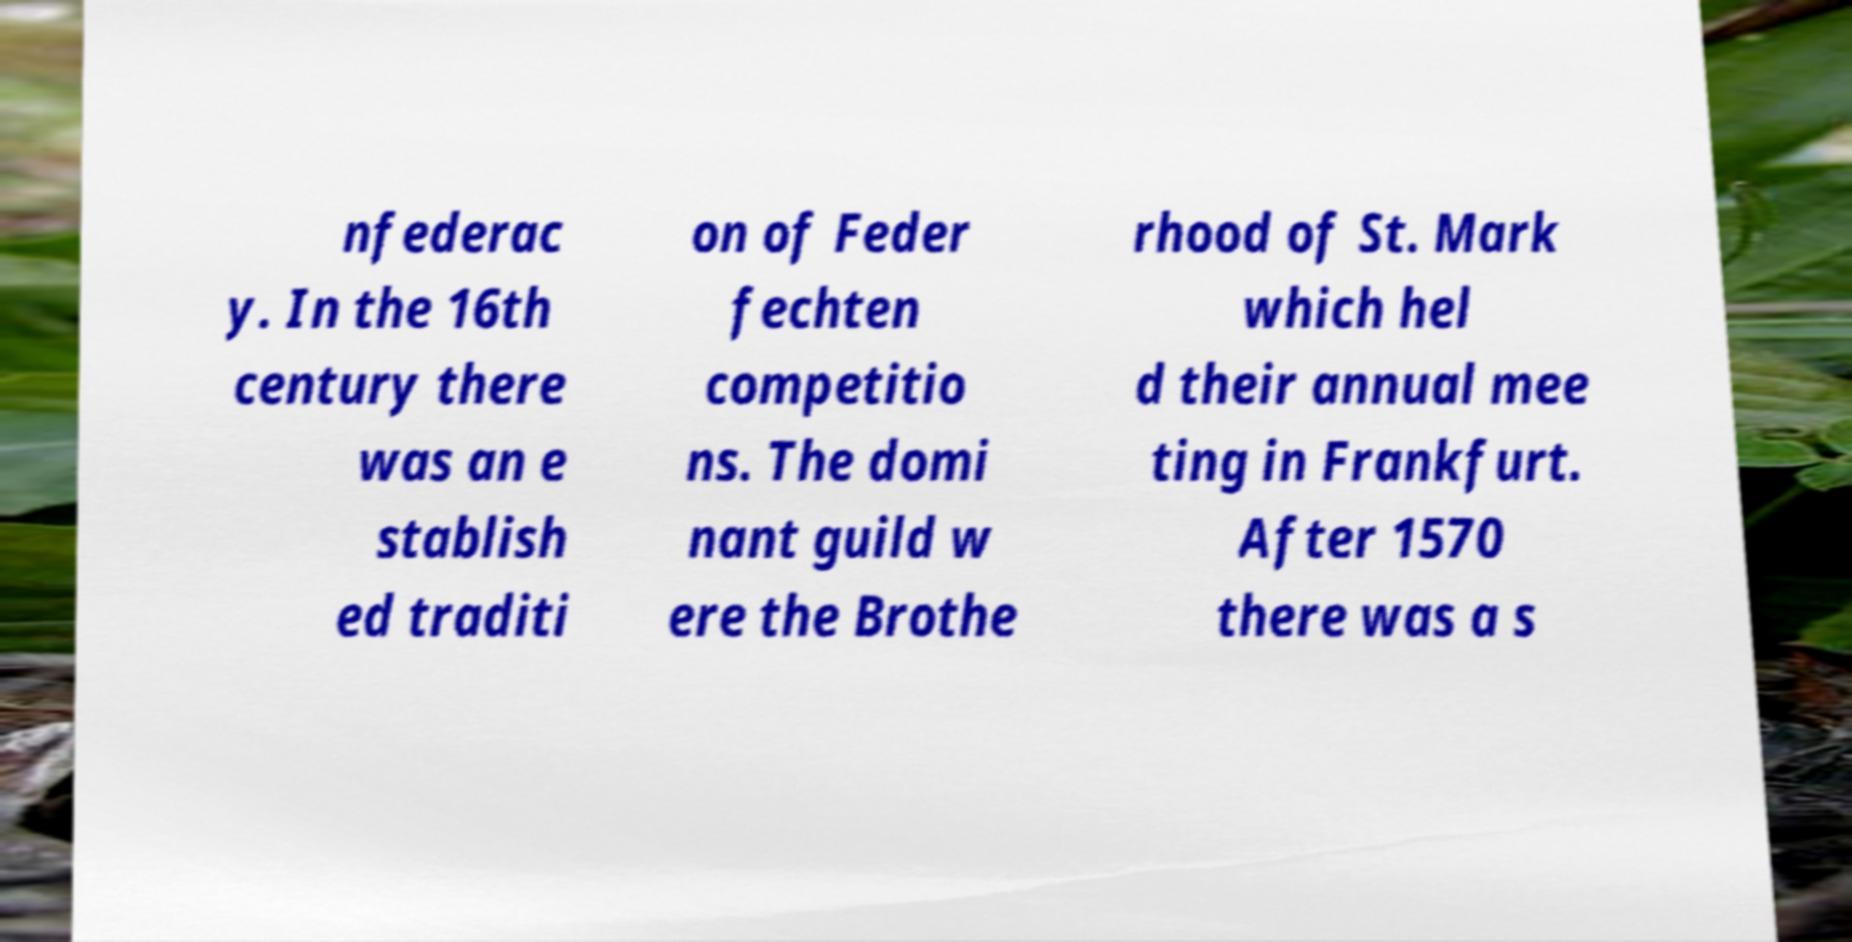Could you assist in decoding the text presented in this image and type it out clearly? nfederac y. In the 16th century there was an e stablish ed traditi on of Feder fechten competitio ns. The domi nant guild w ere the Brothe rhood of St. Mark which hel d their annual mee ting in Frankfurt. After 1570 there was a s 